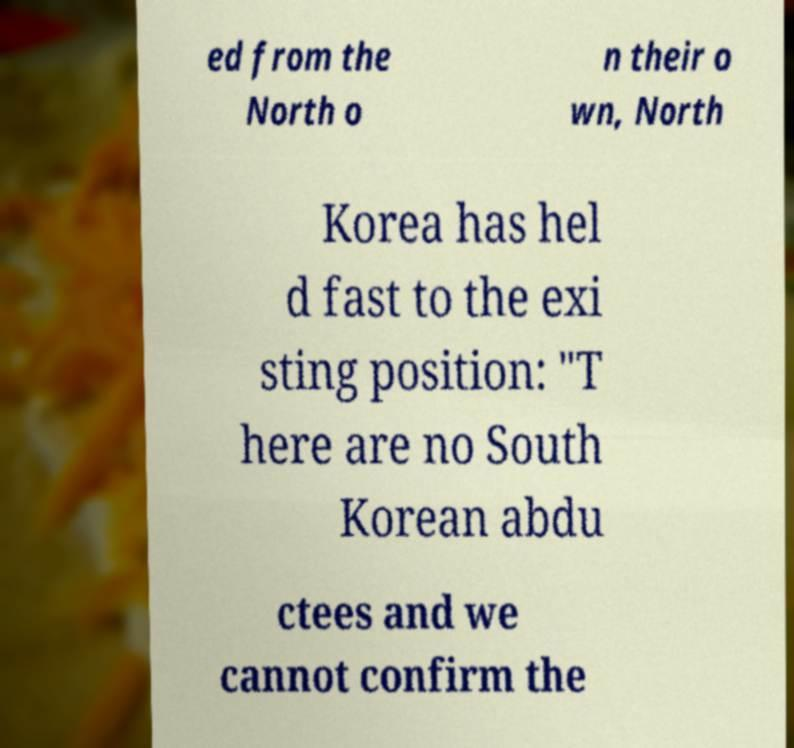I need the written content from this picture converted into text. Can you do that? ed from the North o n their o wn, North Korea has hel d fast to the exi sting position: "T here are no South Korean abdu ctees and we cannot confirm the 